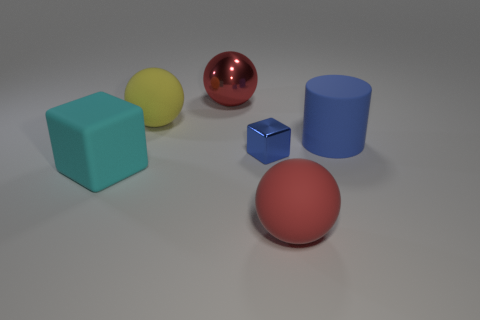Can you describe the texture of the objects? Certainly! The blue cylinder and yellow sphere are matte in texture, which means they scatter light and have a non-reflective surface. The red sphere has a glossy texture, reflecting light and creating a distinct bright spot, known as a highlight. Lastly, the blue cube and the larger, red-orange sphere also appear matte. 